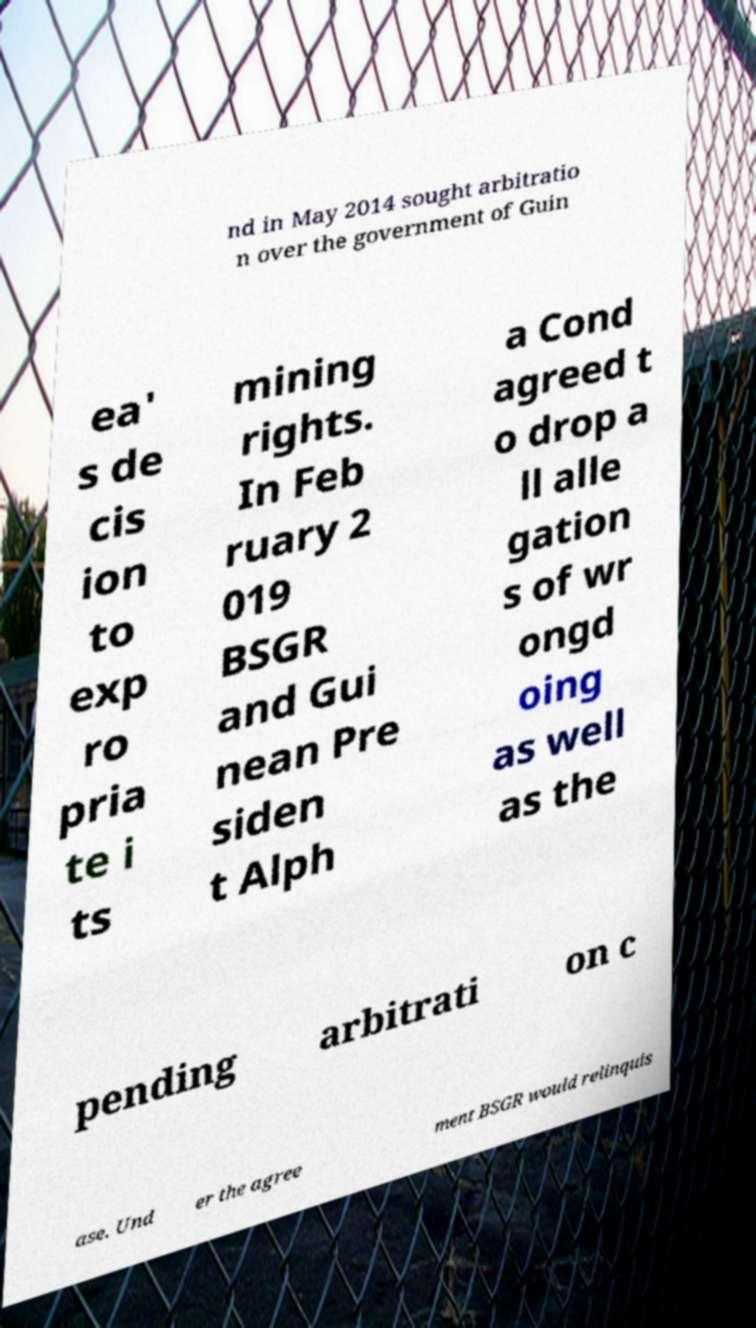Could you assist in decoding the text presented in this image and type it out clearly? nd in May 2014 sought arbitratio n over the government of Guin ea' s de cis ion to exp ro pria te i ts mining rights. In Feb ruary 2 019 BSGR and Gui nean Pre siden t Alph a Cond agreed t o drop a ll alle gation s of wr ongd oing as well as the pending arbitrati on c ase. Und er the agree ment BSGR would relinquis 